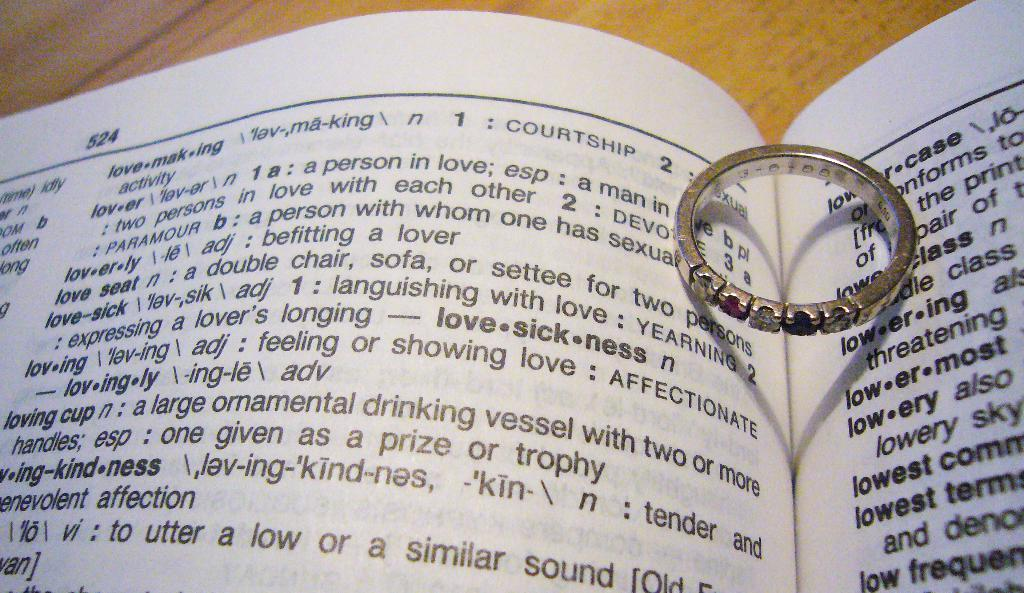<image>
Share a concise interpretation of the image provided. A book that has the work lovesickness in bold next to a wedding ring. 